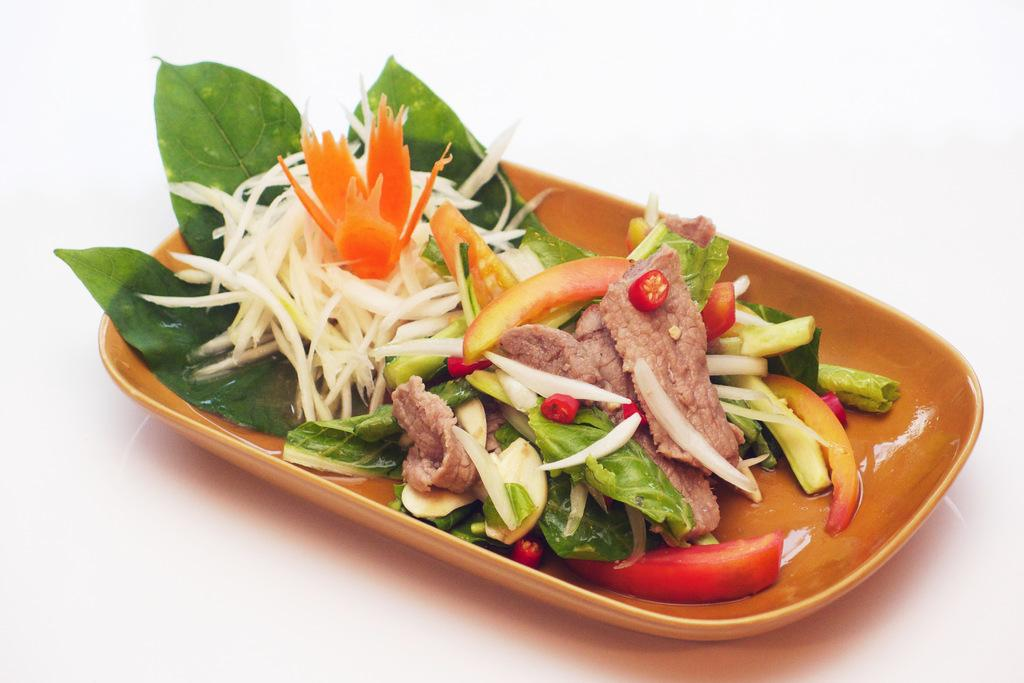What type of food can be seen in the image? There is meat and sliced tomatoes in the image. What dish is visible in the image? There is a salad in the image. Are there any other food items present in the image? Yes, there are other food items in a tray in the image. What color is the ink used to write on the meat in the image? There is no ink or writing on the meat in the image. The meat is simply a food item. 